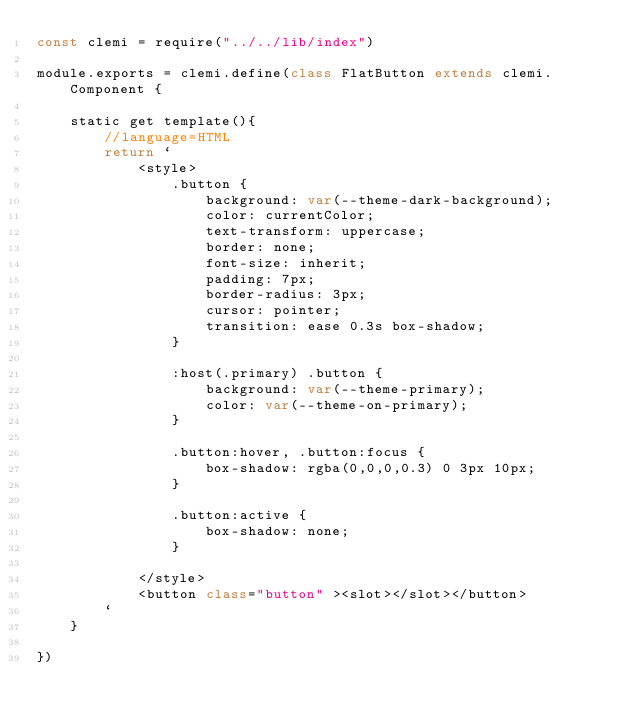Convert code to text. <code><loc_0><loc_0><loc_500><loc_500><_JavaScript_>const clemi = require("../../lib/index")

module.exports = clemi.define(class FlatButton extends clemi.Component {

    static get template(){
        //language=HTML
        return `
            <style>
                .button {
                    background: var(--theme-dark-background);
                    color: currentColor;
                    text-transform: uppercase;
                    border: none;
                    font-size: inherit;
                    padding: 7px;
                    border-radius: 3px;
                    cursor: pointer;
                    transition: ease 0.3s box-shadow;
                }
                
                :host(.primary) .button {
                    background: var(--theme-primary);
                    color: var(--theme-on-primary);
                }
                
                .button:hover, .button:focus {
                    box-shadow: rgba(0,0,0,0.3) 0 3px 10px;
                }
                
                .button:active {
                    box-shadow: none;
                }
                
            </style>
            <button class="button" ><slot></slot></button>
        `
    }

})</code> 